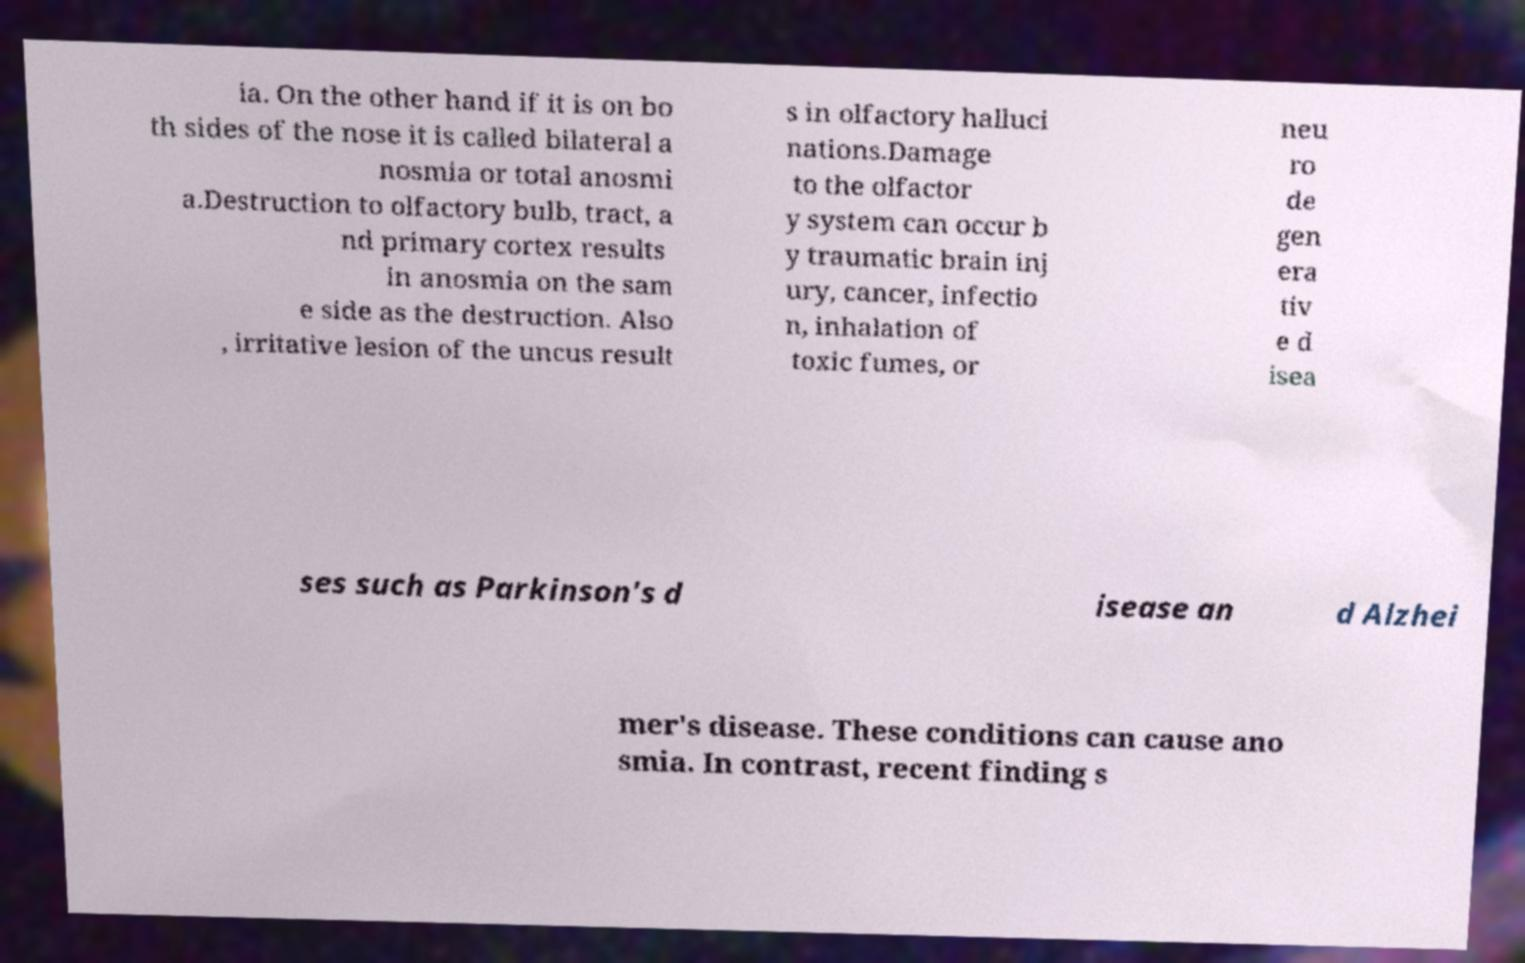Can you accurately transcribe the text from the provided image for me? ia. On the other hand if it is on bo th sides of the nose it is called bilateral a nosmia or total anosmi a.Destruction to olfactory bulb, tract, a nd primary cortex results in anosmia on the sam e side as the destruction. Also , irritative lesion of the uncus result s in olfactory halluci nations.Damage to the olfactor y system can occur b y traumatic brain inj ury, cancer, infectio n, inhalation of toxic fumes, or neu ro de gen era tiv e d isea ses such as Parkinson's d isease an d Alzhei mer's disease. These conditions can cause ano smia. In contrast, recent finding s 